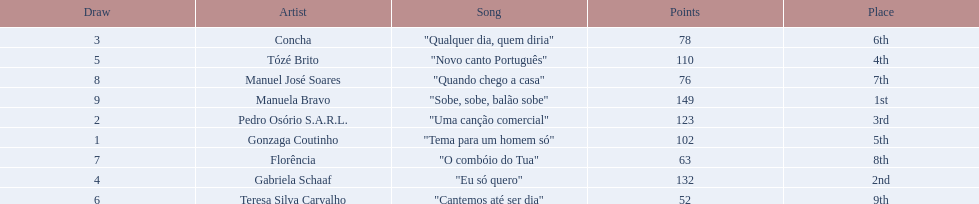Which artists sang in the eurovision song contest of 1979? Gonzaga Coutinho, Pedro Osório S.A.R.L., Concha, Gabriela Schaaf, Tózé Brito, Teresa Silva Carvalho, Florência, Manuel José Soares, Manuela Bravo. Of these, who sang eu so quero? Gabriela Schaaf. 